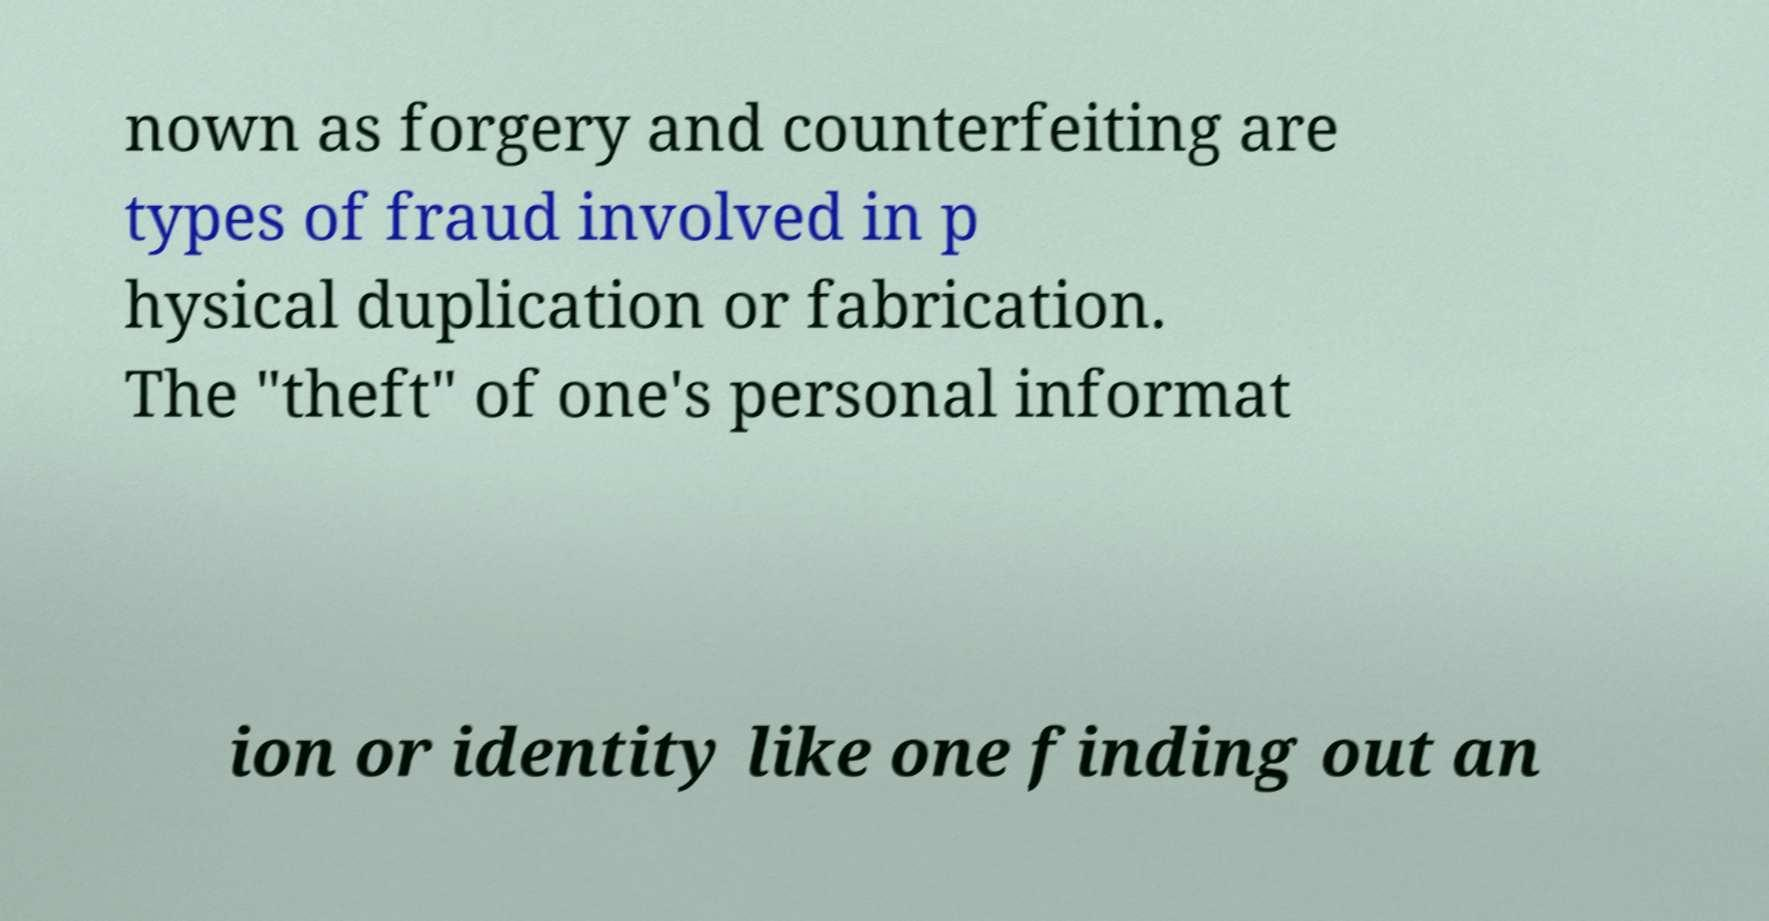Please identify and transcribe the text found in this image. nown as forgery and counterfeiting are types of fraud involved in p hysical duplication or fabrication. The "theft" of one's personal informat ion or identity like one finding out an 